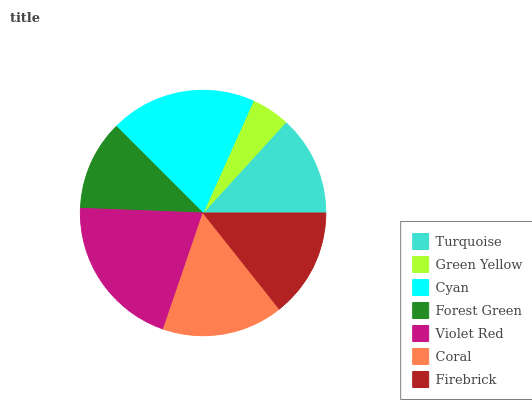Is Green Yellow the minimum?
Answer yes or no. Yes. Is Violet Red the maximum?
Answer yes or no. Yes. Is Cyan the minimum?
Answer yes or no. No. Is Cyan the maximum?
Answer yes or no. No. Is Cyan greater than Green Yellow?
Answer yes or no. Yes. Is Green Yellow less than Cyan?
Answer yes or no. Yes. Is Green Yellow greater than Cyan?
Answer yes or no. No. Is Cyan less than Green Yellow?
Answer yes or no. No. Is Firebrick the high median?
Answer yes or no. Yes. Is Firebrick the low median?
Answer yes or no. Yes. Is Coral the high median?
Answer yes or no. No. Is Cyan the low median?
Answer yes or no. No. 